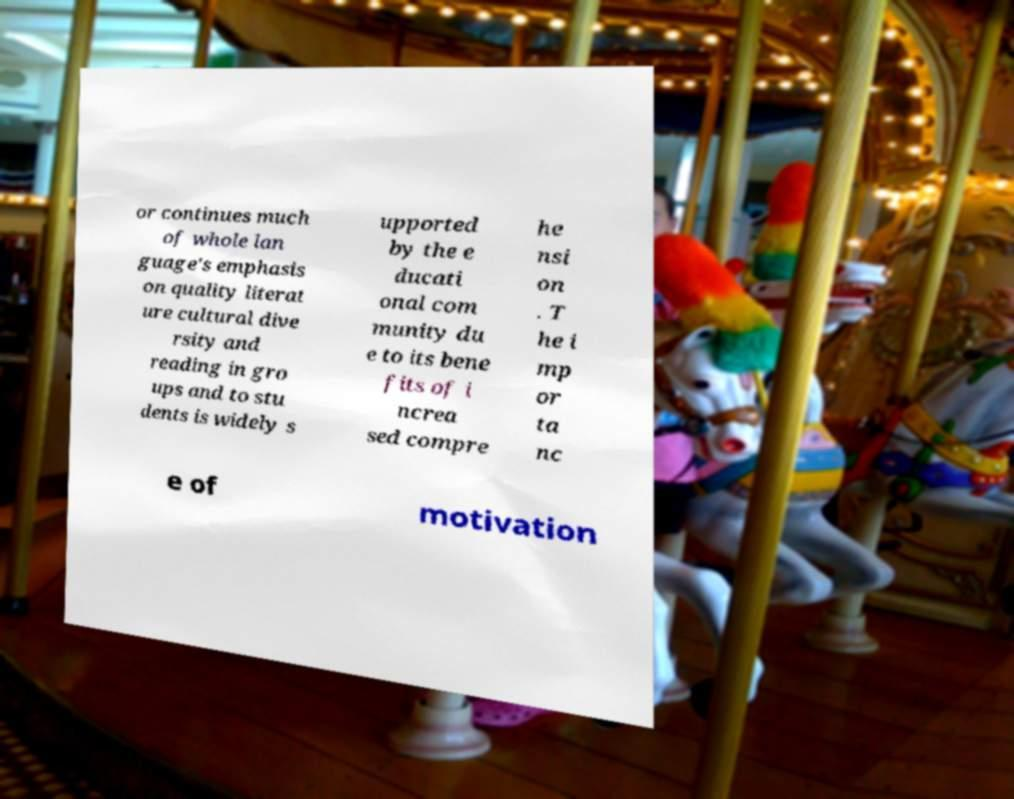There's text embedded in this image that I need extracted. Can you transcribe it verbatim? or continues much of whole lan guage's emphasis on quality literat ure cultural dive rsity and reading in gro ups and to stu dents is widely s upported by the e ducati onal com munity du e to its bene fits of i ncrea sed compre he nsi on . T he i mp or ta nc e of motivation 